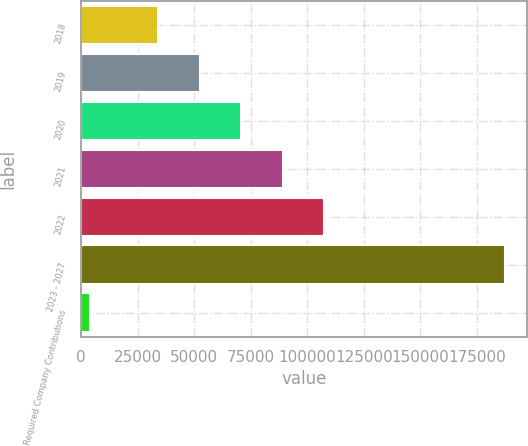<chart> <loc_0><loc_0><loc_500><loc_500><bar_chart><fcel>2018<fcel>2019<fcel>2020<fcel>2021<fcel>2022<fcel>2023 - 2027<fcel>Required Company Contributions<nl><fcel>33992<fcel>52339.9<fcel>70687.8<fcel>89035.7<fcel>107384<fcel>187600<fcel>4121<nl></chart> 